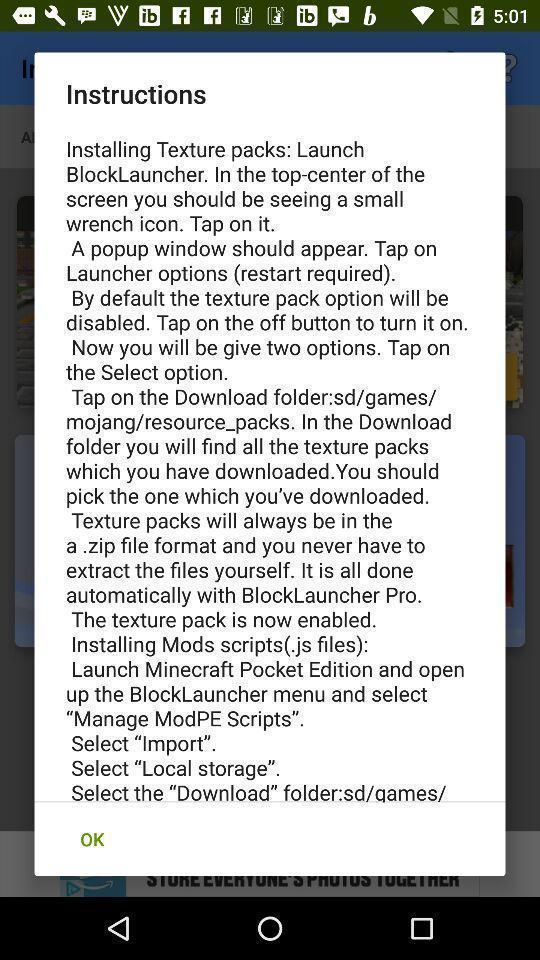What can you discern from this picture? Pop-up showing the list of instructions. 